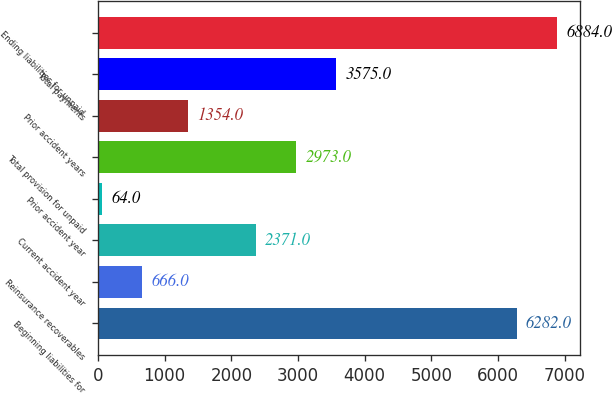Convert chart. <chart><loc_0><loc_0><loc_500><loc_500><bar_chart><fcel>Beginning liabilities for<fcel>Reinsurance recoverables<fcel>Current accident year<fcel>Prior accident year<fcel>Total provision for unpaid<fcel>Prior accident years<fcel>Total payments<fcel>Ending liabilities for unpaid<nl><fcel>6282<fcel>666<fcel>2371<fcel>64<fcel>2973<fcel>1354<fcel>3575<fcel>6884<nl></chart> 